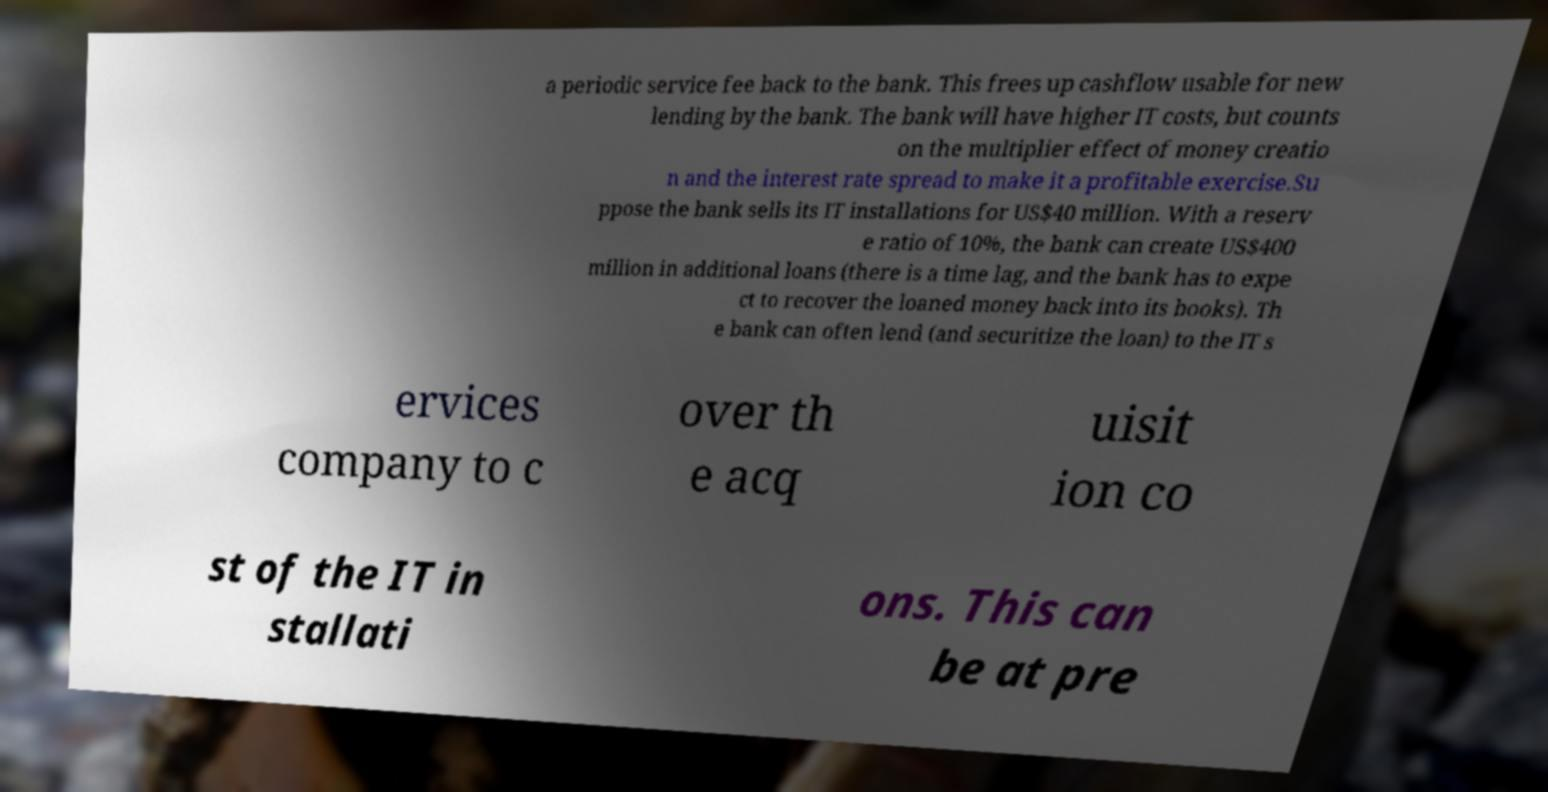There's text embedded in this image that I need extracted. Can you transcribe it verbatim? a periodic service fee back to the bank. This frees up cashflow usable for new lending by the bank. The bank will have higher IT costs, but counts on the multiplier effect of money creatio n and the interest rate spread to make it a profitable exercise.Su ppose the bank sells its IT installations for US$40 million. With a reserv e ratio of 10%, the bank can create US$400 million in additional loans (there is a time lag, and the bank has to expe ct to recover the loaned money back into its books). Th e bank can often lend (and securitize the loan) to the IT s ervices company to c over th e acq uisit ion co st of the IT in stallati ons. This can be at pre 